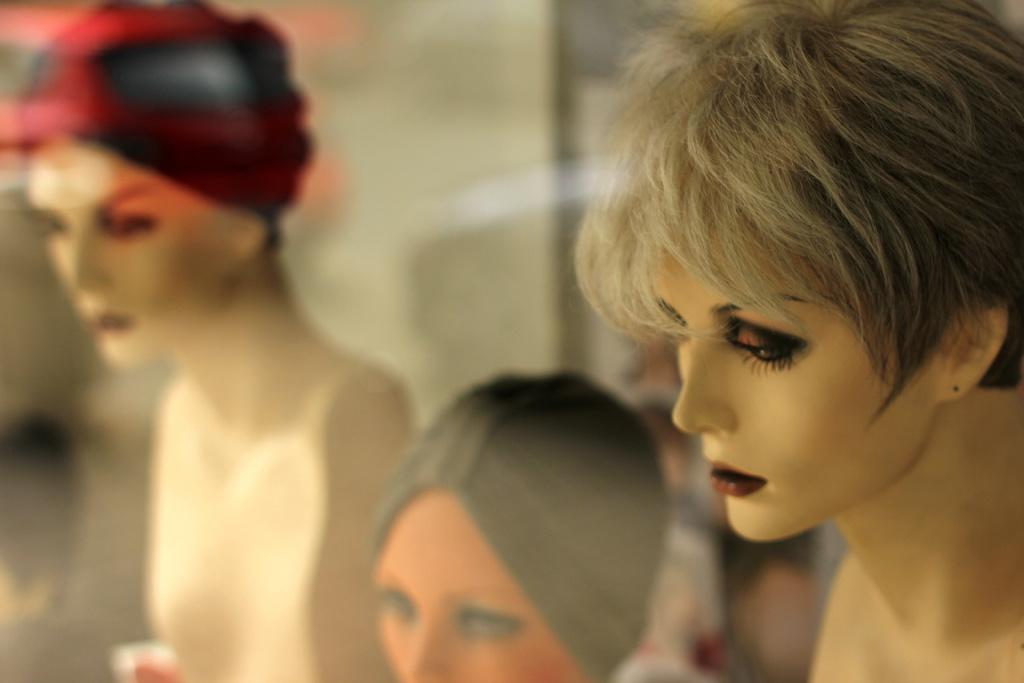What type of figures are present in the image? There are female mannequins in the image. Can you describe the background of the image? The background of the image is blurry. What type of grass can be seen growing in the image? There is no grass present in the image; it only features female mannequins and a blurry background. 